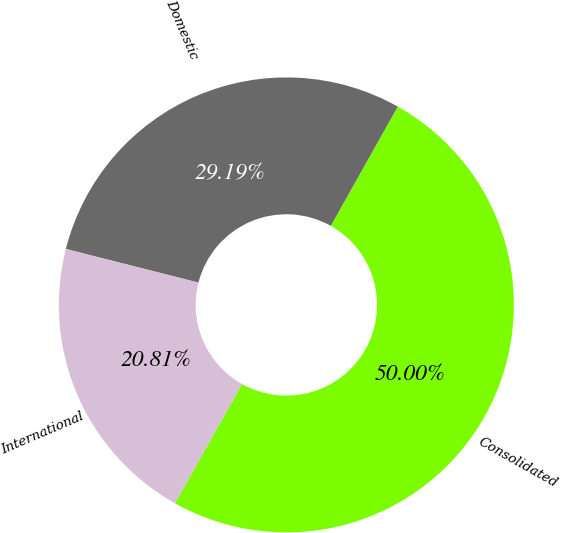Convert chart to OTSL. <chart><loc_0><loc_0><loc_500><loc_500><pie_chart><fcel>Consolidated<fcel>Domestic<fcel>International<nl><fcel>50.0%<fcel>29.19%<fcel>20.81%<nl></chart> 